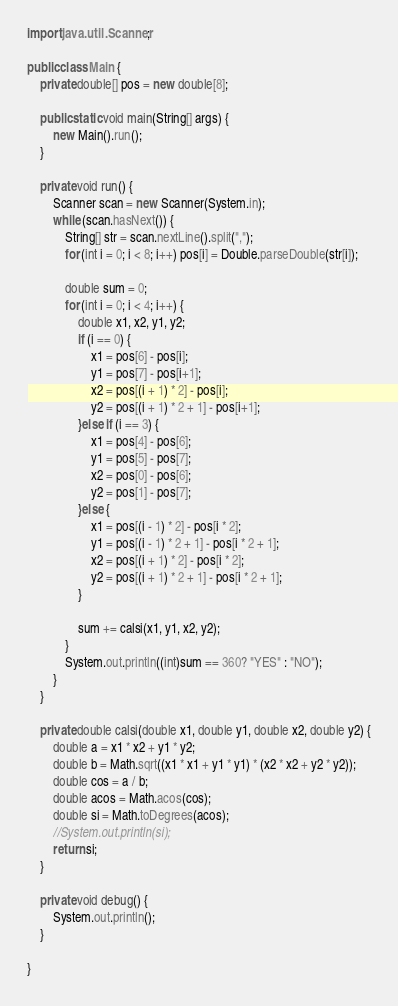Convert code to text. <code><loc_0><loc_0><loc_500><loc_500><_Java_>import java.util.Scanner;

public class Main {
	private double[] pos = new double[8];

	public static void main(String[] args) {
		new Main().run();
	}
	
	private void run() {
		Scanner scan = new Scanner(System.in);
		while (scan.hasNext()) {
			String[] str = scan.nextLine().split(",");
			for (int i = 0; i < 8; i++) pos[i] = Double.parseDouble(str[i]);
			
			double sum = 0;
			for (int i = 0; i < 4; i++) {
				double x1, x2, y1, y2;
				if (i == 0) {
					x1 = pos[6] - pos[i];
					y1 = pos[7] - pos[i+1];
					x2 = pos[(i + 1) * 2] - pos[i];
					y2 = pos[(i + 1) * 2 + 1] - pos[i+1];
				}else if (i == 3) {
					x1 = pos[4] - pos[6];
					y1 = pos[5] - pos[7];
					x2 = pos[0] - pos[6];
					y2 = pos[1] - pos[7];
				}else {
					x1 = pos[(i - 1) * 2] - pos[i * 2];
					y1 = pos[(i - 1) * 2 + 1] - pos[i * 2 + 1];
					x2 = pos[(i + 1) * 2] - pos[i * 2];
					y2 = pos[(i + 1) * 2 + 1] - pos[i * 2 + 1];
				}
				
				sum += calsi(x1, y1, x2, y2);
			}
			System.out.println((int)sum == 360? "YES" : "NO");
		}
	}
	
	private double calsi(double x1, double y1, double x2, double y2) {
		double a = x1 * x2 + y1 * y2;
		double b = Math.sqrt((x1 * x1 + y1 * y1) * (x2 * x2 + y2 * y2));
		double cos = a / b;
		double acos = Math.acos(cos);
		double si = Math.toDegrees(acos);
		//System.out.println(si);
		return si;
	}
	
	private void debug() {
		System.out.println();
	}

}</code> 